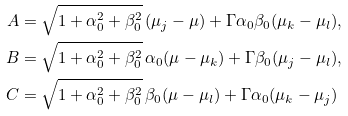<formula> <loc_0><loc_0><loc_500><loc_500>A & = \sqrt { 1 + \alpha _ { 0 } ^ { 2 } + \beta _ { 0 } ^ { 2 } } \, ( \mu _ { j } - \mu ) + \Gamma \alpha _ { 0 } \beta _ { 0 } ( \mu _ { k } - \mu _ { l } ) , \\ B & = \sqrt { 1 + \alpha _ { 0 } ^ { 2 } + \beta _ { 0 } ^ { 2 } } \, \alpha _ { 0 } ( \mu - \mu _ { k } ) + \Gamma \beta _ { 0 } ( \mu _ { j } - \mu _ { l } ) , \\ C & = \sqrt { 1 + \alpha _ { 0 } ^ { 2 } + \beta _ { 0 } ^ { 2 } } \, \beta _ { 0 } ( \mu - \mu _ { l } ) + \Gamma \alpha _ { 0 } ( \mu _ { k } - \mu _ { j } )</formula> 